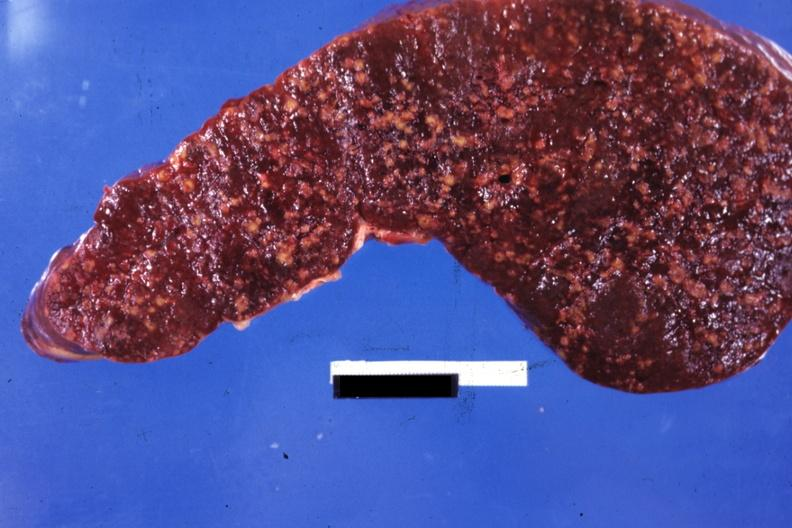does splenomegaly with cirrhosis show cut surface multiple nodular lesions?
Answer the question using a single word or phrase. No 